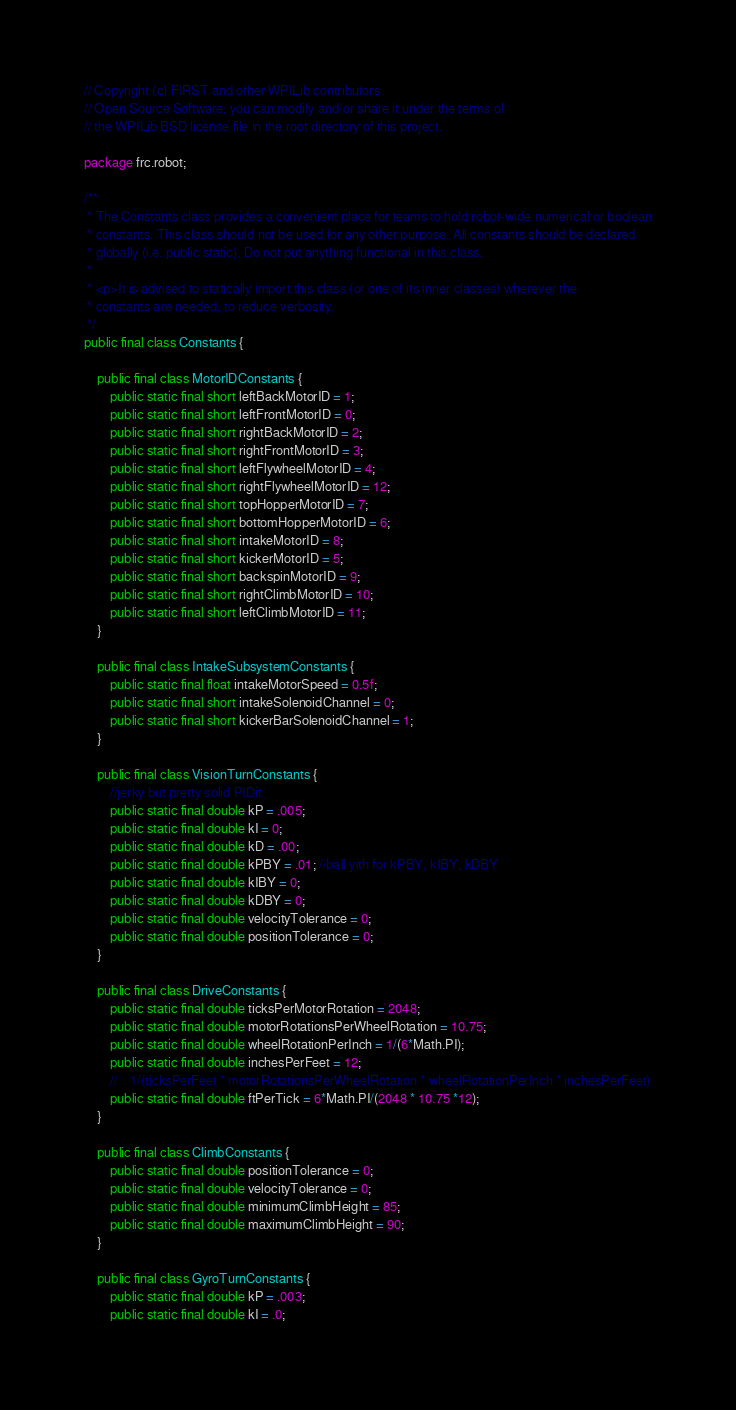<code> <loc_0><loc_0><loc_500><loc_500><_Java_>// Copyright (c) FIRST and other WPILib contributors.
// Open Source Software; you can modify and/or share it under the terms of
// the WPILib BSD license file in the root directory of this project.

package frc.robot;

/**
 * The Constants class provides a convenient place for teams to hold robot-wide numerical or boolean
 * constants. This class should not be used for any other purpose. All constants should be declared
 * globally (i.e. public static). Do not put anything functional in this class.
 *
 * <p>It is advised to statically import this class (or one of its inner classes) wherever the
 * constants are needed, to reduce verbosity.
 */
public final class Constants {

    public final class MotorIDConstants {
        public static final short leftBackMotorID = 1;
        public static final short leftFrontMotorID = 0;
        public static final short rightBackMotorID = 2;
        public static final short rightFrontMotorID = 3;
        public static final short leftFlywheelMotorID = 4;
        public static final short rightFlywheelMotorID = 12;
        public static final short topHopperMotorID = 7;
        public static final short bottomHopperMotorID = 6;
        public static final short intakeMotorID = 8;
        public static final short kickerMotorID = 5;
        public static final short backspinMotorID = 9;
        public static final short rightClimbMotorID = 10;
        public static final short leftClimbMotorID = 11;
    }

    public final class IntakeSubsystemConstants {
        public static final float intakeMotorSpeed = 0.5f;
        public static final short intakeSolenoidChannel = 0;
        public static final short kickerBarSolenoidChannel = 1;
    }

    public final class VisionTurnConstants {
        //jerky but pretty solid PIDit
        public static final double kP = .005;
        public static final double kI = 0;
        public static final double kD = .00;
        public static final double kPBY = .01; //ball yith for kPBY, kIBY, kDBY
        public static final double kIBY = 0;
        public static final double kDBY = 0;
        public static final double velocityTolerance = 0;
        public static final double positionTolerance = 0;
    }

    public final class DriveConstants {
        public static final double ticksPerMotorRotation = 2048;
        public static final double motorRotationsPerWheelRotation = 10.75;
        public static final double wheelRotationPerInch = 1/(6*Math.PI);
        public static final double inchesPerFeet = 12;
        //    1/(ticksPerFeet * motorRotationsPerWheelRotation * wheelRotationPerInch * inchesPerFeet)
        public static final double ftPerTick = 6*Math.PI/(2048 * 10.75 *12);
    }

    public final class ClimbConstants {
        public static final double positionTolerance = 0;
        public static final double velocityTolerance = 0;
        public static final double minimumClimbHeight = 85;
        public static final double maximumClimbHeight = 90;
    }

    public final class GyroTurnConstants {
        public static final double kP = .003;
        public static final double kI = .0;</code> 